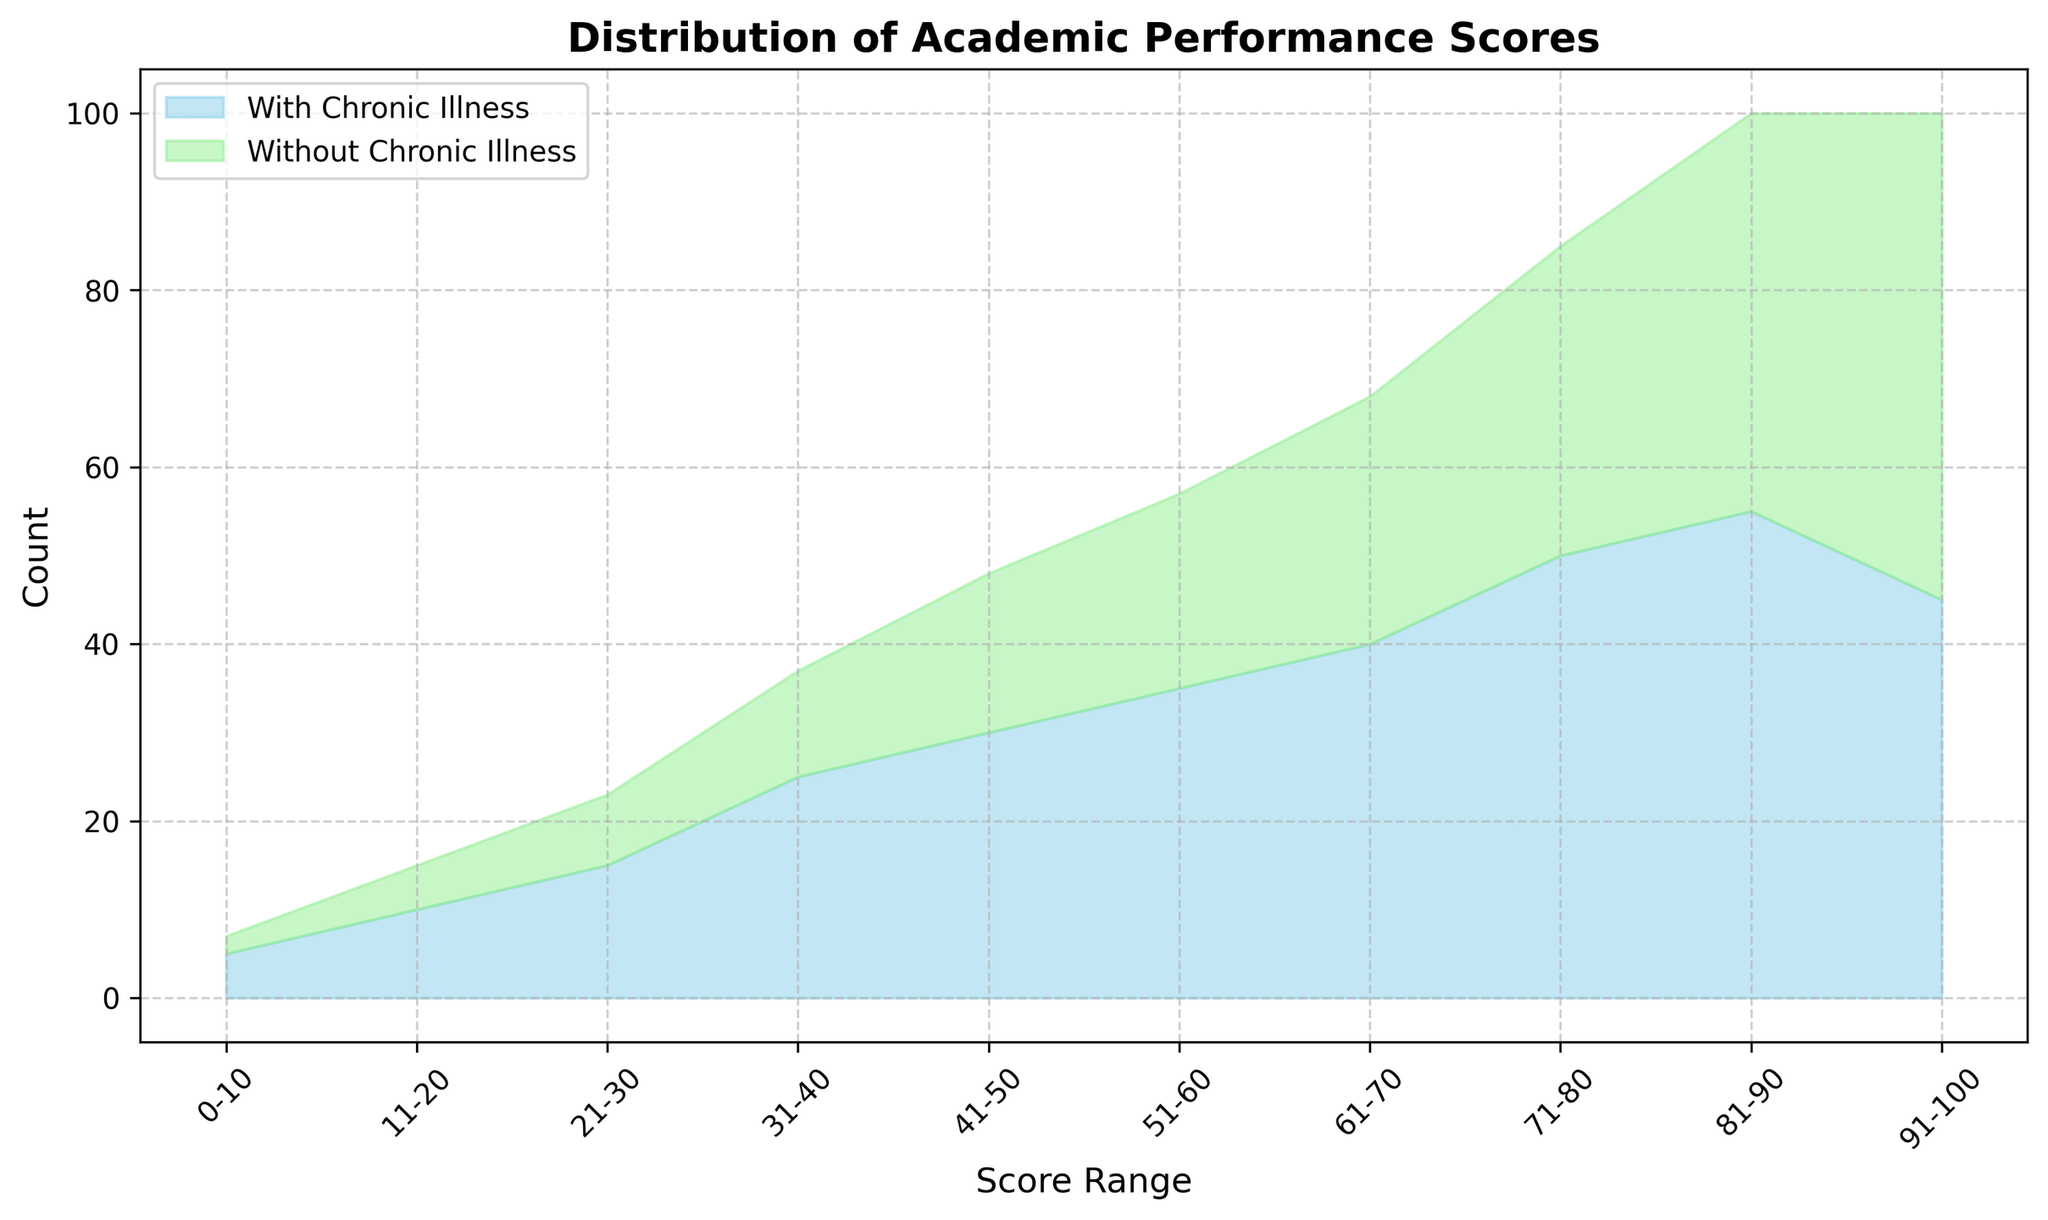What is the highest count of students in a score range for those without chronic illness? Look at the chart area for "Without Chronic Illness" and identify the highest peak. The highest peak corresponds to the 91-100 score range.
Answer: 55 What is the combined total count of students in the 41-50 score range for both groups? Sum the counts for both groups in the 41-50 score range: 30 (with chronic illness) + 18 (without chronic illness).
Answer: 48 Which score range shows a higher count of students with chronic illness compared to those without chronic illness? Compare the area heights of the two groups across the score ranges and identify where the count for "With Chronic Illness" (blue) is higher than "Without Chronic Illness" (green). The 81-90 range fits this.
Answer: 81-90 In which score range do both groups have an equal count? Identify the score range where the heights of both groups' areas are equal. This occurs in the 91-100 range.
Answer: 91-100 What is the difference in the total count of students in the 71-80 score range between the two groups? Subtract the count of "With Chronic Illness" (50) from "Without Chronic Illness" (35): 50 - 35.
Answer: 15 How many score ranges have higher counts for "Without Chronic Illness" students compared to "With Chronic Illness" students? Count the score ranges where "Without Chronic Illness" (green) areas are taller than "With Chronic Illness" (blue). These ranges are 91-100 and 81-90.
Answer: 2 Which score range shows the largest difference between the two groups in favor of "With Chronic Illness"? Find the score range with the maximum difference where "With Chronic Illness" is greater than "Without Chronic Illness". This is 21-30 with a difference of 15 - 8 = 7.
Answer: 21-30 What is the total count of students with chronic illness scoring above 70? Add the counts for "With Chronic Illness" students scoring 71-80 (50), 81-90 (55), and 91-100 (45). Total = 50 + 55 + 45.
Answer: 150 Which group has a larger total population of students in the illustrated score ranges? Compare the overall filled areas of both groups; sum up the counts for each score range for both groups. "With Chronic Illness" total = 310, "Without Chronic Illness" total = 230.
Answer: With Chronic Illness In which score range is the difference between the two groups the smallest? Find the score range where the difference between the counts of "With Chronic Illness" and "Without Chronic Illness" is minimal. This occurs in the 51-60 range: 35 - 22 = 13.
Answer: 51-60 